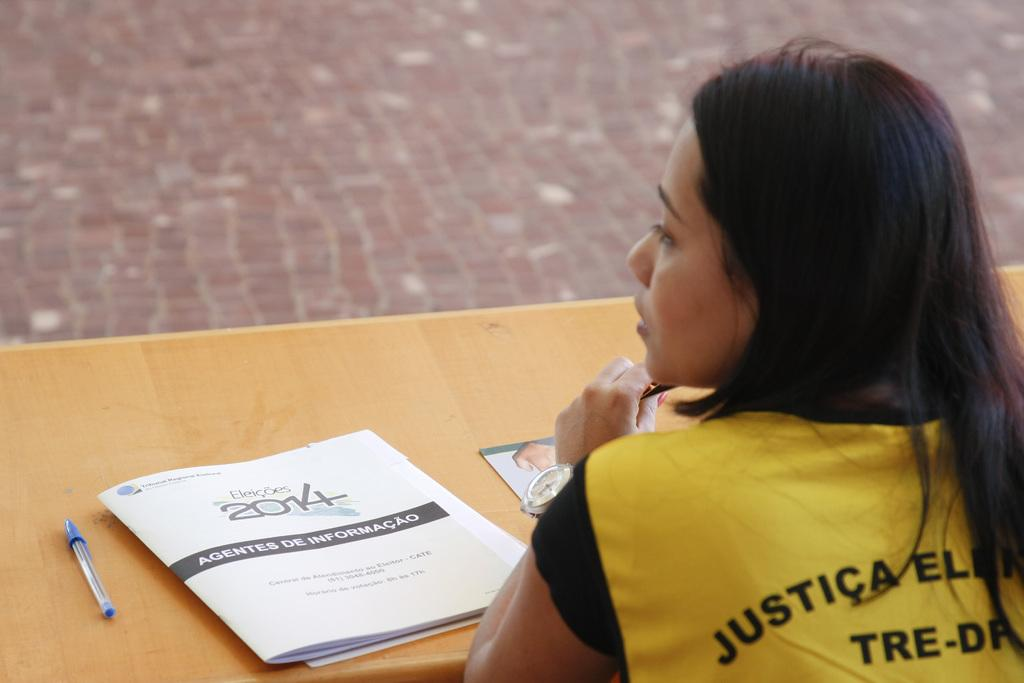Who is the main subject in the picture? There is a girl in the picture. Where is the girl positioned in relation to the table? The girl is in front of a table. What objects are on the table? There is a pen and a book on the table. How many people are present at the cemetery in the image? There is no cemetery present in the image, and therefore no people at a cemetery can be observed. 